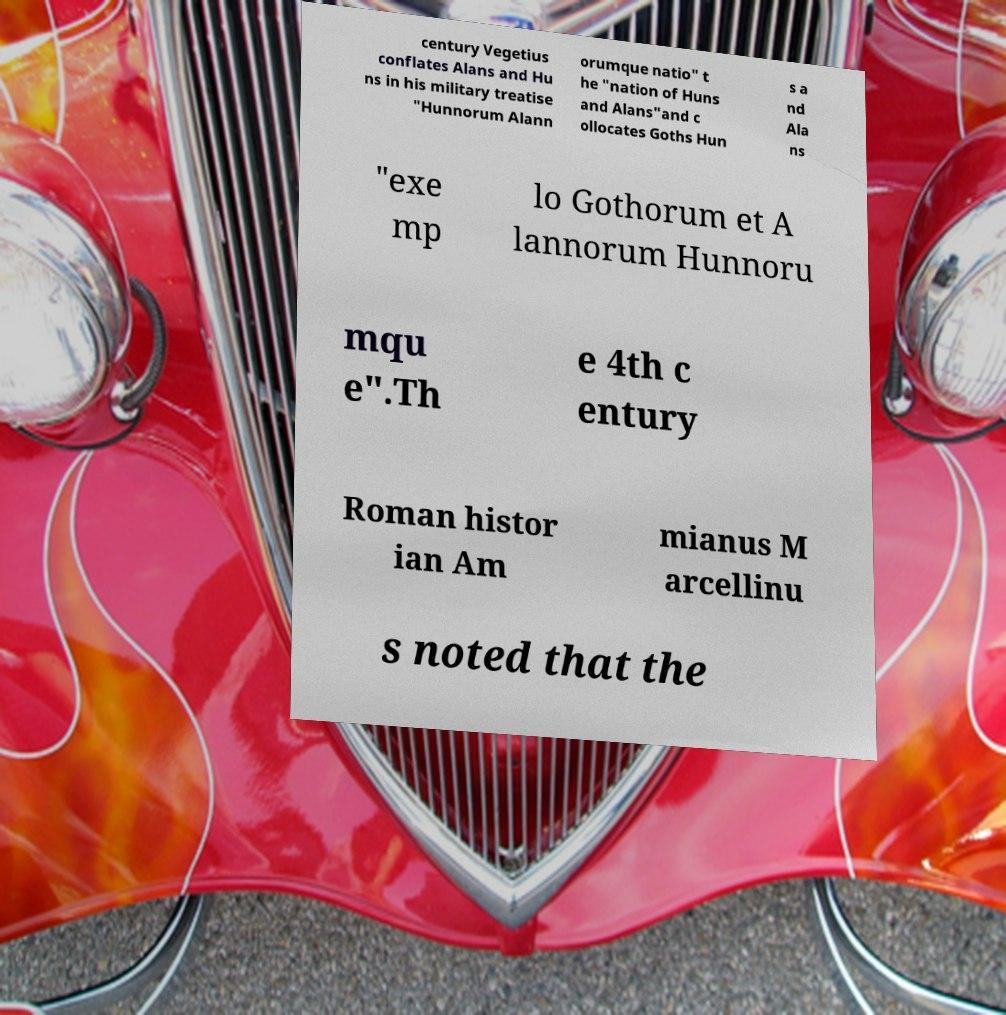Please read and relay the text visible in this image. What does it say? century Vegetius conflates Alans and Hu ns in his military treatise "Hunnorum Alann orumque natio" t he "nation of Huns and Alans"and c ollocates Goths Hun s a nd Ala ns "exe mp lo Gothorum et A lannorum Hunnoru mqu e".Th e 4th c entury Roman histor ian Am mianus M arcellinu s noted that the 